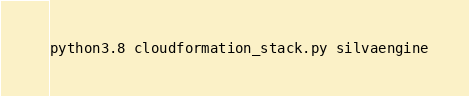<code> <loc_0><loc_0><loc_500><loc_500><_Bash_>
python3.8 cloudformation_stack.py silvaengine</code> 